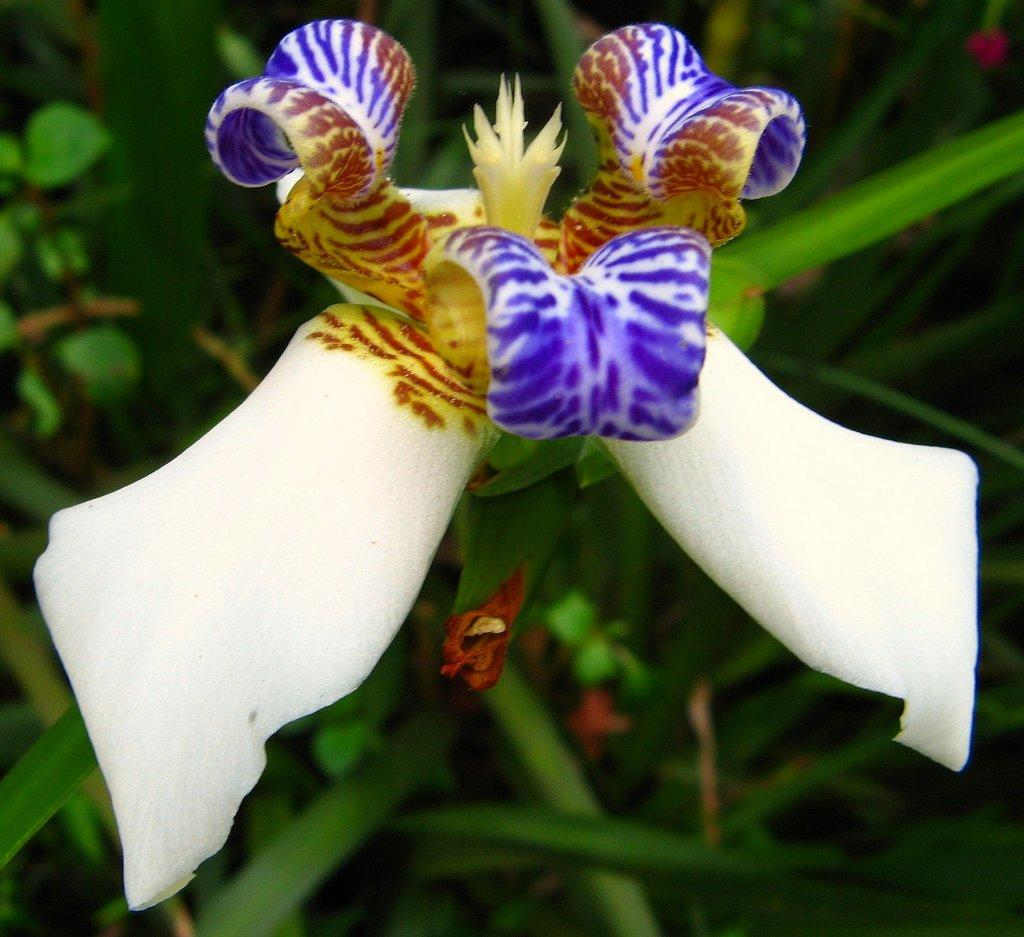What is the main subject of the picture? The main subject of the picture is a flower. Can you describe the background of the picture? There are plants in the background of the picture. How does the river flow through the flower in the image? There is no river present in the image; it features a flower and plants in the background. What type of leaf can be seen inside the stomach of the flower in the image? There is no leaf or stomach present in the image; it features a flower and plants in the background. 